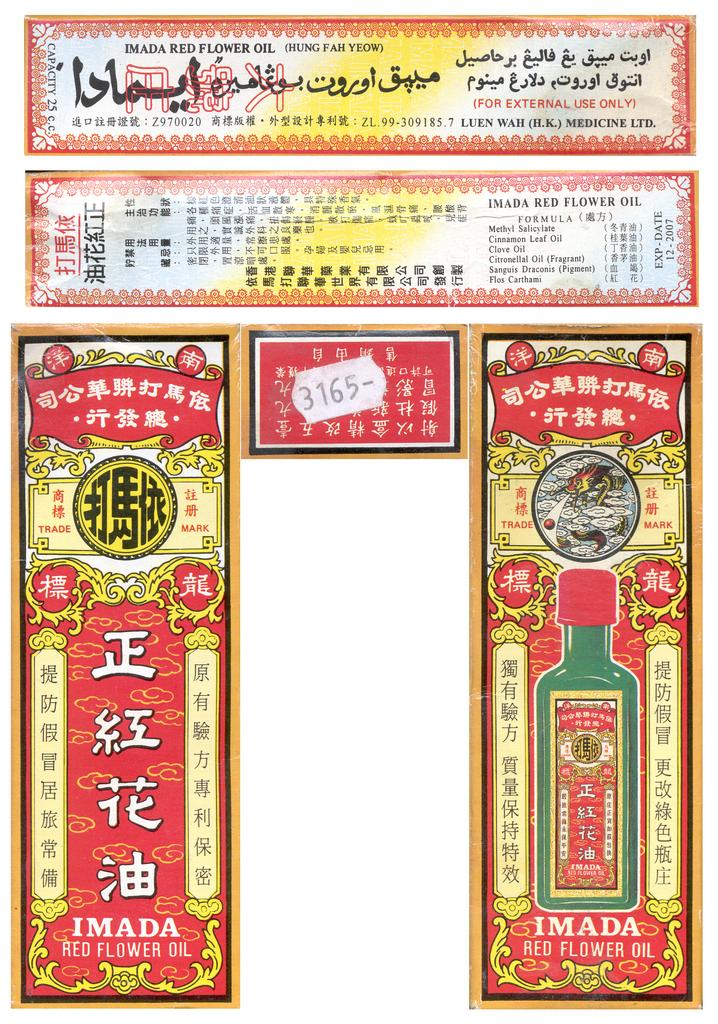<image>
Present a compact description of the photo's key features. colorful ads for Imada Red Flower oil with arabic and chinese writing 